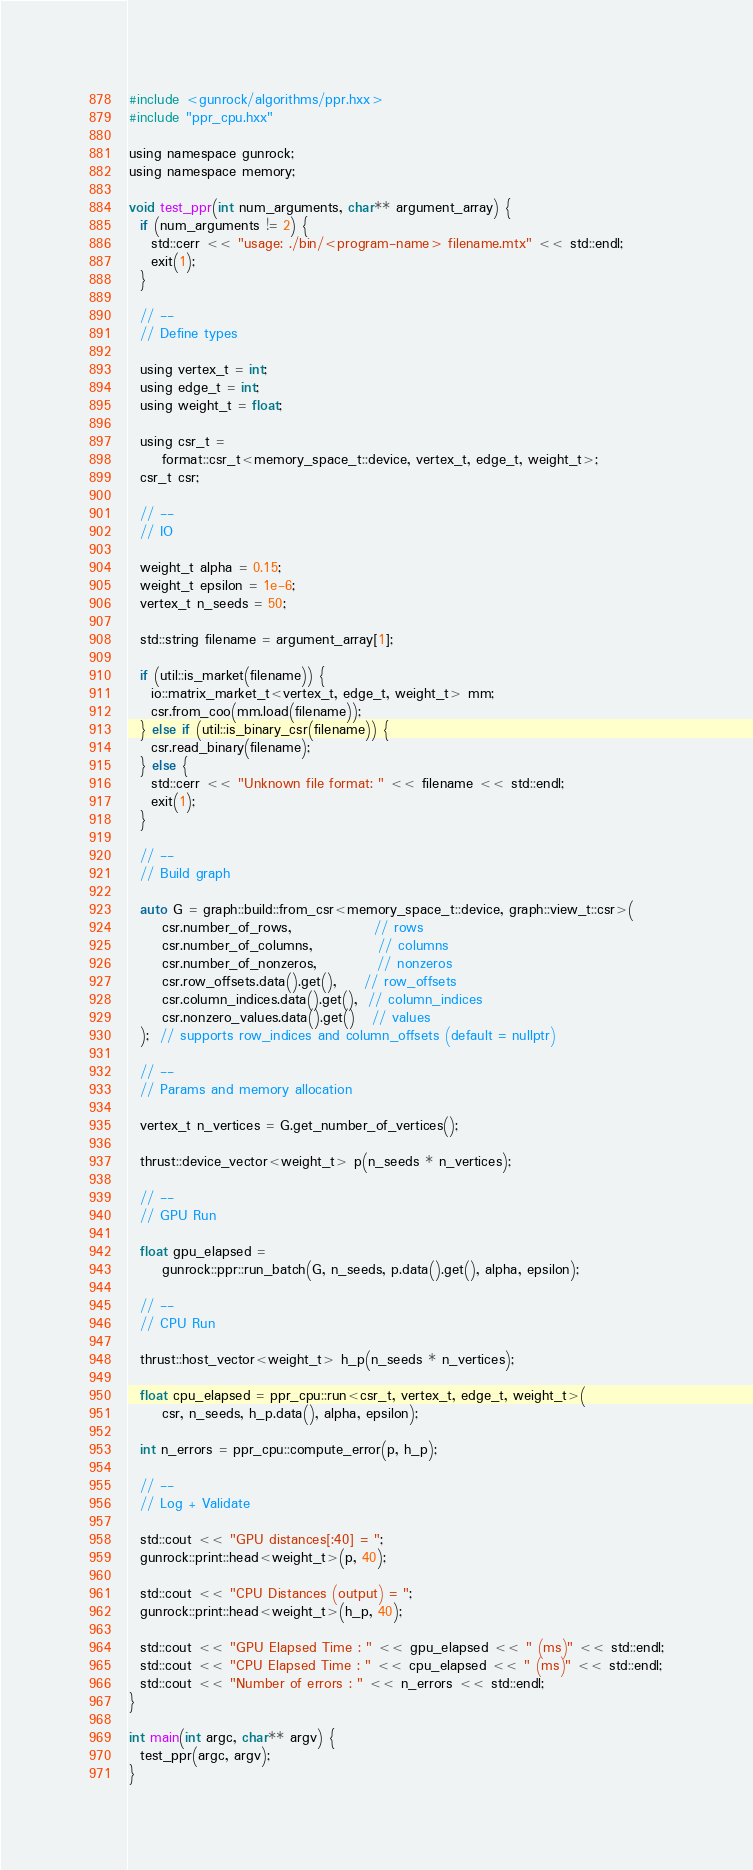<code> <loc_0><loc_0><loc_500><loc_500><_Cuda_>#include <gunrock/algorithms/ppr.hxx>
#include "ppr_cpu.hxx"

using namespace gunrock;
using namespace memory;

void test_ppr(int num_arguments, char** argument_array) {
  if (num_arguments != 2) {
    std::cerr << "usage: ./bin/<program-name> filename.mtx" << std::endl;
    exit(1);
  }

  // --
  // Define types

  using vertex_t = int;
  using edge_t = int;
  using weight_t = float;

  using csr_t =
      format::csr_t<memory_space_t::device, vertex_t, edge_t, weight_t>;
  csr_t csr;

  // --
  // IO

  weight_t alpha = 0.15;
  weight_t epsilon = 1e-6;
  vertex_t n_seeds = 50;

  std::string filename = argument_array[1];

  if (util::is_market(filename)) {
    io::matrix_market_t<vertex_t, edge_t, weight_t> mm;
    csr.from_coo(mm.load(filename));
  } else if (util::is_binary_csr(filename)) {
    csr.read_binary(filename);
  } else {
    std::cerr << "Unknown file format: " << filename << std::endl;
    exit(1);
  }

  // --
  // Build graph

  auto G = graph::build::from_csr<memory_space_t::device, graph::view_t::csr>(
      csr.number_of_rows,               // rows
      csr.number_of_columns,            // columns
      csr.number_of_nonzeros,           // nonzeros
      csr.row_offsets.data().get(),     // row_offsets
      csr.column_indices.data().get(),  // column_indices
      csr.nonzero_values.data().get()   // values
  );  // supports row_indices and column_offsets (default = nullptr)

  // --
  // Params and memory allocation

  vertex_t n_vertices = G.get_number_of_vertices();

  thrust::device_vector<weight_t> p(n_seeds * n_vertices);

  // --
  // GPU Run

  float gpu_elapsed =
      gunrock::ppr::run_batch(G, n_seeds, p.data().get(), alpha, epsilon);

  // --
  // CPU Run

  thrust::host_vector<weight_t> h_p(n_seeds * n_vertices);

  float cpu_elapsed = ppr_cpu::run<csr_t, vertex_t, edge_t, weight_t>(
      csr, n_seeds, h_p.data(), alpha, epsilon);

  int n_errors = ppr_cpu::compute_error(p, h_p);

  // --
  // Log + Validate

  std::cout << "GPU distances[:40] = ";
  gunrock::print::head<weight_t>(p, 40);

  std::cout << "CPU Distances (output) = ";
  gunrock::print::head<weight_t>(h_p, 40);

  std::cout << "GPU Elapsed Time : " << gpu_elapsed << " (ms)" << std::endl;
  std::cout << "CPU Elapsed Time : " << cpu_elapsed << " (ms)" << std::endl;
  std::cout << "Number of errors : " << n_errors << std::endl;
}

int main(int argc, char** argv) {
  test_ppr(argc, argv);
}
</code> 